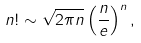Convert formula to latex. <formula><loc_0><loc_0><loc_500><loc_500>n ! \sim { \sqrt { 2 \pi n } } \left ( { \frac { n } { e } } \right ) ^ { n } ,</formula> 